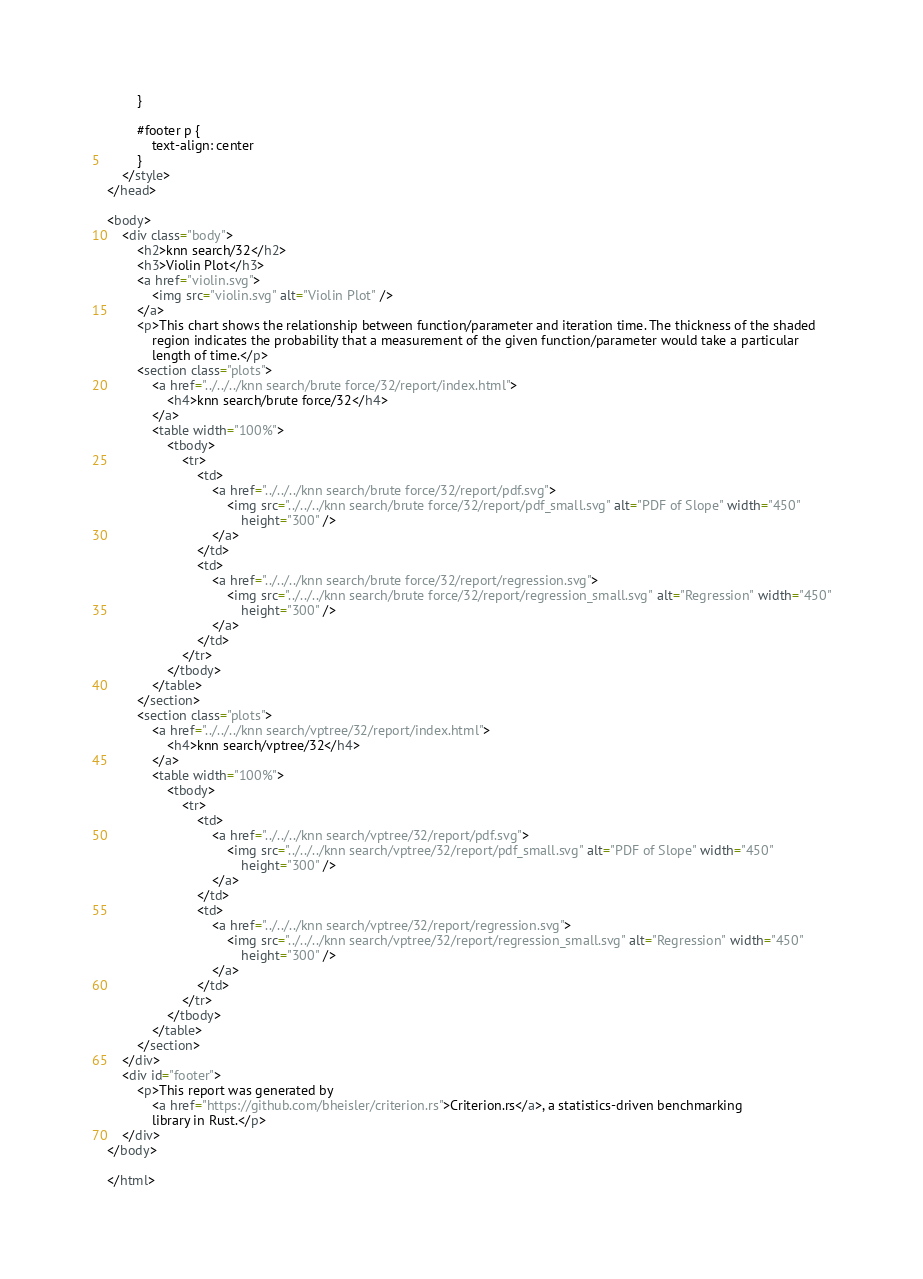Convert code to text. <code><loc_0><loc_0><loc_500><loc_500><_HTML_>        }

        #footer p {
            text-align: center
        }
    </style>
</head>

<body>
    <div class="body">
        <h2>knn search/32</h2>
        <h3>Violin Plot</h3>
        <a href="violin.svg">
            <img src="violin.svg" alt="Violin Plot" />
        </a>
        <p>This chart shows the relationship between function/parameter and iteration time. The thickness of the shaded
            region indicates the probability that a measurement of the given function/parameter would take a particular
            length of time.</p>
        <section class="plots">
            <a href="../../../knn search/brute force/32/report/index.html">
                <h4>knn search/brute force/32</h4>
            </a>
            <table width="100%">
                <tbody>
                    <tr>
                        <td>
                            <a href="../../../knn search/brute force/32/report/pdf.svg">
                                <img src="../../../knn search/brute force/32/report/pdf_small.svg" alt="PDF of Slope" width="450"
                                    height="300" />
                            </a>
                        </td>
                        <td>
                            <a href="../../../knn search/brute force/32/report/regression.svg">
                                <img src="../../../knn search/brute force/32/report/regression_small.svg" alt="Regression" width="450"
                                    height="300" />
                            </a>
                        </td>
                    </tr>
                </tbody>
            </table>
        </section>
        <section class="plots">
            <a href="../../../knn search/vptree/32/report/index.html">
                <h4>knn search/vptree/32</h4>
            </a>
            <table width="100%">
                <tbody>
                    <tr>
                        <td>
                            <a href="../../../knn search/vptree/32/report/pdf.svg">
                                <img src="../../../knn search/vptree/32/report/pdf_small.svg" alt="PDF of Slope" width="450"
                                    height="300" />
                            </a>
                        </td>
                        <td>
                            <a href="../../../knn search/vptree/32/report/regression.svg">
                                <img src="../../../knn search/vptree/32/report/regression_small.svg" alt="Regression" width="450"
                                    height="300" />
                            </a>
                        </td>
                    </tr>
                </tbody>
            </table>
        </section>
    </div>
    <div id="footer">
        <p>This report was generated by
            <a href="https://github.com/bheisler/criterion.rs">Criterion.rs</a>, a statistics-driven benchmarking
            library in Rust.</p>
    </div>
</body>

</html></code> 